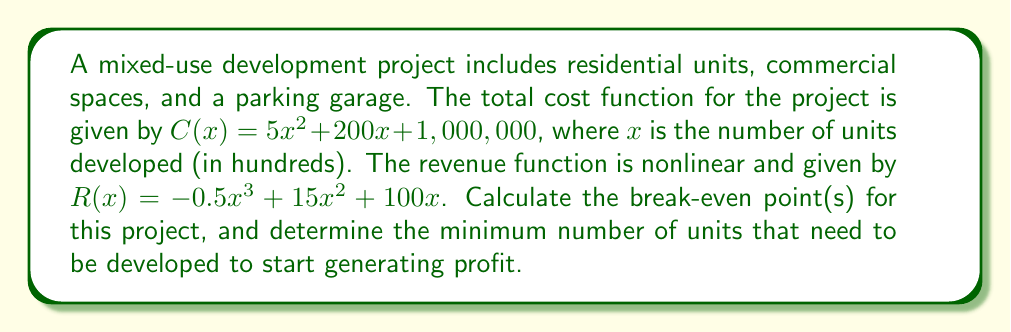What is the answer to this math problem? To find the break-even point(s), we need to solve the equation where revenue equals cost:

1. Set up the equation:
   $R(x) = C(x)$
   $-0.5x^3 + 15x^2 + 100x = 5x^2 + 200x + 1,000,000$

2. Rearrange the equation:
   $-0.5x^3 + 10x^2 - 100x - 1,000,000 = 0$

3. Multiply all terms by -2 to simplify:
   $x^3 - 20x^2 + 200x + 2,000,000 = 0$

4. This is a cubic equation. We can solve it using the cubic formula or a numerical method. Using a numerical solver, we find the roots:

   $x_1 \approx 4.47$
   $x_2 \approx 10.76$
   $x_3 \approx 104.77$

5. Interpret the results:
   - The project breaks even at approximately 447, 1,076, and 10,477 units.
   - The minimum number of units to start generating profit is 1,076 units.

6. Verify by calculating profit at each point:
   For $x = 4.47$: $R(4.47) - C(4.47) \approx 0$
   For $x = 10.76$: $R(10.76) - C(10.76) \approx 0$
   For $x = 104.77$: $R(104.77) - C(104.77) \approx 0$

   For $x > 10.76$ and $x < 104.77$, profit is positive.
Answer: Break-even points: 447, 1,076, and 10,477 units. Minimum for profit: 1,076 units. 